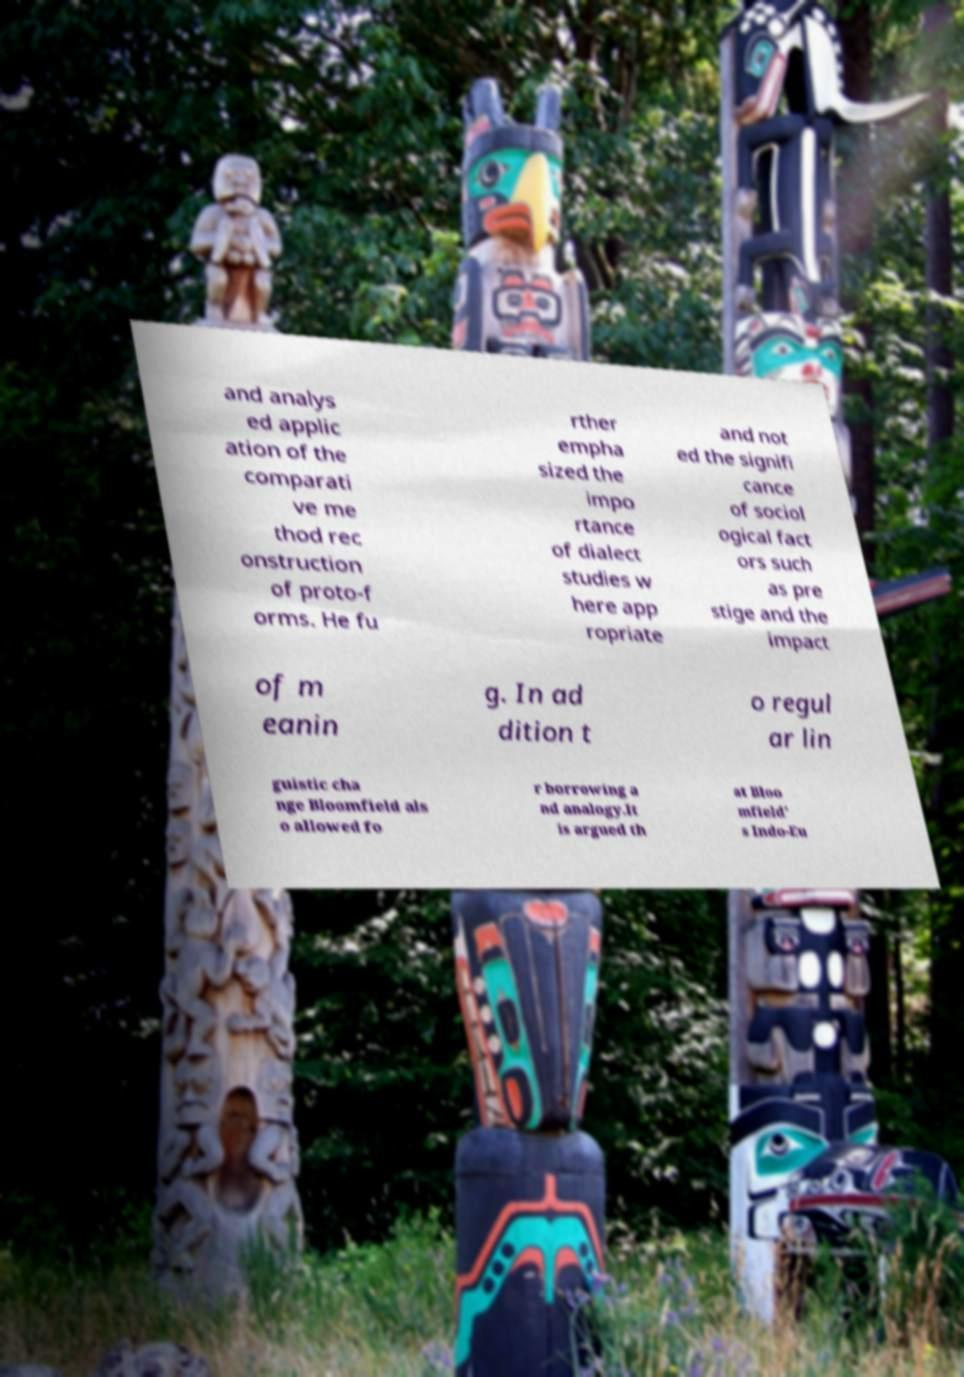Please identify and transcribe the text found in this image. and analys ed applic ation of the comparati ve me thod rec onstruction of proto-f orms. He fu rther empha sized the impo rtance of dialect studies w here app ropriate and not ed the signifi cance of sociol ogical fact ors such as pre stige and the impact of m eanin g. In ad dition t o regul ar lin guistic cha nge Bloomfield als o allowed fo r borrowing a nd analogy.It is argued th at Bloo mfield' s Indo-Eu 